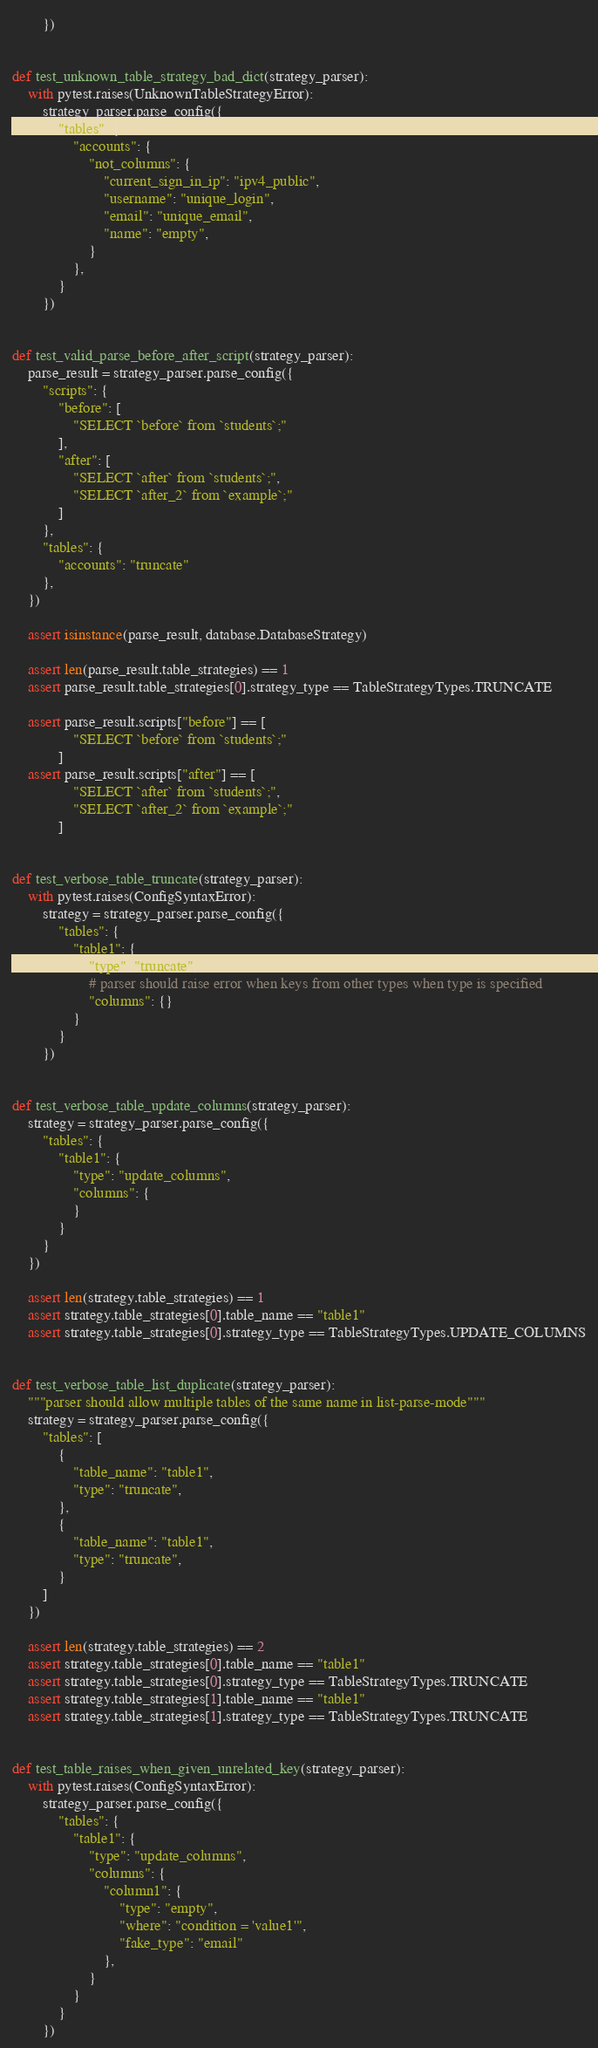Convert code to text. <code><loc_0><loc_0><loc_500><loc_500><_Python_>        })


def test_unknown_table_strategy_bad_dict(strategy_parser):
    with pytest.raises(UnknownTableStrategyError):
        strategy_parser.parse_config({
            "tables": {
                "accounts": {
                    "not_columns": {
                        "current_sign_in_ip": "ipv4_public",
                        "username": "unique_login",
                        "email": "unique_email",
                        "name": "empty",
                    }
                },
            }
        })


def test_valid_parse_before_after_script(strategy_parser):
    parse_result = strategy_parser.parse_config({
        "scripts": {
            "before": [
                "SELECT `before` from `students`;"
            ],
            "after": [
                "SELECT `after` from `students`;",
                "SELECT `after_2` from `example`;"
            ]
        },
        "tables": {
            "accounts": "truncate"
        },
    })

    assert isinstance(parse_result, database.DatabaseStrategy)

    assert len(parse_result.table_strategies) == 1
    assert parse_result.table_strategies[0].strategy_type == TableStrategyTypes.TRUNCATE

    assert parse_result.scripts["before"] == [
                "SELECT `before` from `students`;"
            ]
    assert parse_result.scripts["after"] == [
                "SELECT `after` from `students`;",
                "SELECT `after_2` from `example`;"
            ]


def test_verbose_table_truncate(strategy_parser):
    with pytest.raises(ConfigSyntaxError):
        strategy = strategy_parser.parse_config({
            "tables": {
                "table1": {
                    "type": "truncate",
                    # parser should raise error when keys from other types when type is specified
                    "columns": {}
                }
            }
        })


def test_verbose_table_update_columns(strategy_parser):
    strategy = strategy_parser.parse_config({
        "tables": {
            "table1": {
                "type": "update_columns",
                "columns": {
                }
            }
        }
    })

    assert len(strategy.table_strategies) == 1
    assert strategy.table_strategies[0].table_name == "table1"
    assert strategy.table_strategies[0].strategy_type == TableStrategyTypes.UPDATE_COLUMNS


def test_verbose_table_list_duplicate(strategy_parser):
    """parser should allow multiple tables of the same name in list-parse-mode"""
    strategy = strategy_parser.parse_config({
        "tables": [
            {
                "table_name": "table1",
                "type": "truncate",
            },
            {
                "table_name": "table1",
                "type": "truncate",
            }
        ]
    })

    assert len(strategy.table_strategies) == 2
    assert strategy.table_strategies[0].table_name == "table1"
    assert strategy.table_strategies[0].strategy_type == TableStrategyTypes.TRUNCATE
    assert strategy.table_strategies[1].table_name == "table1"
    assert strategy.table_strategies[1].strategy_type == TableStrategyTypes.TRUNCATE


def test_table_raises_when_given_unrelated_key(strategy_parser):
    with pytest.raises(ConfigSyntaxError):
        strategy_parser.parse_config({
            "tables": {
                "table1": {
                    "type": "update_columns",
                    "columns": {
                        "column1": {
                            "type": "empty",
                            "where": "condition = 'value1'",
                            "fake_type": "email"
                        },
                    }
                }
            }
        })</code> 